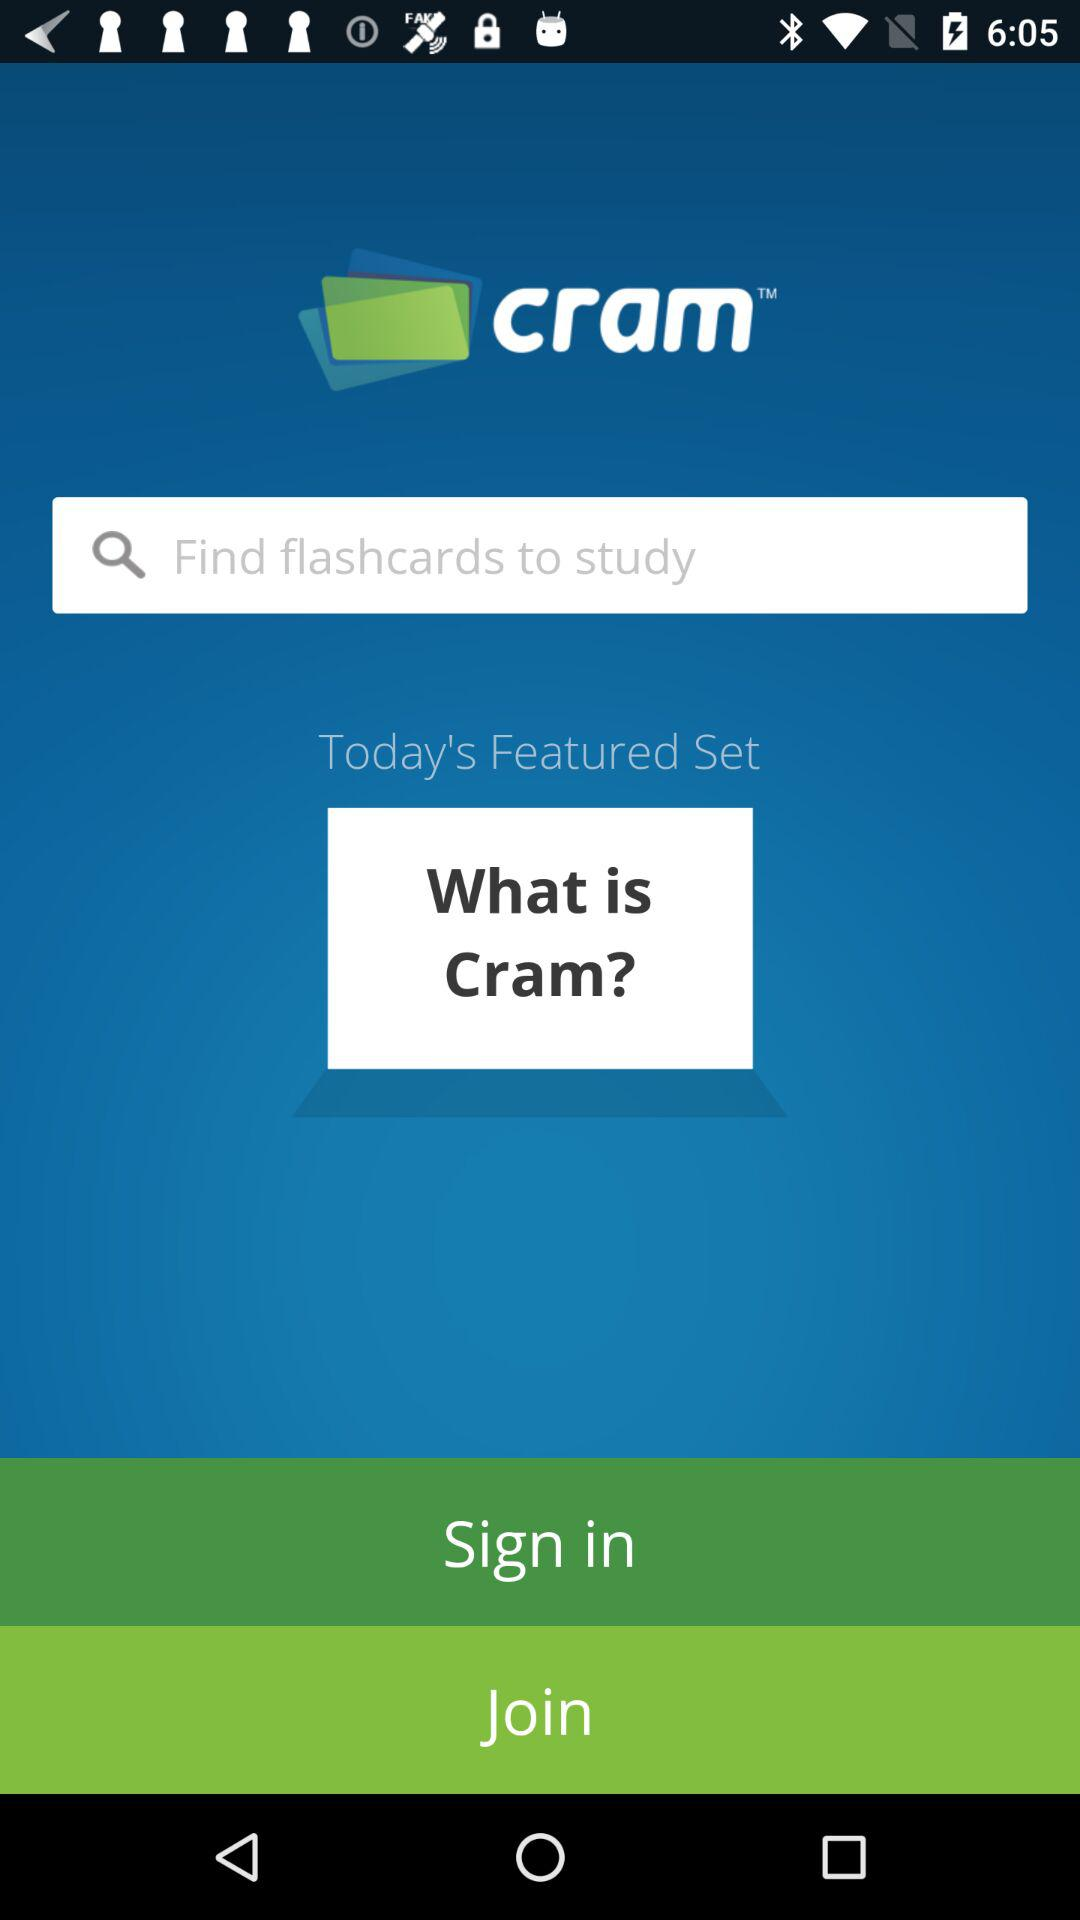What is the application name? The application name is "cram". 